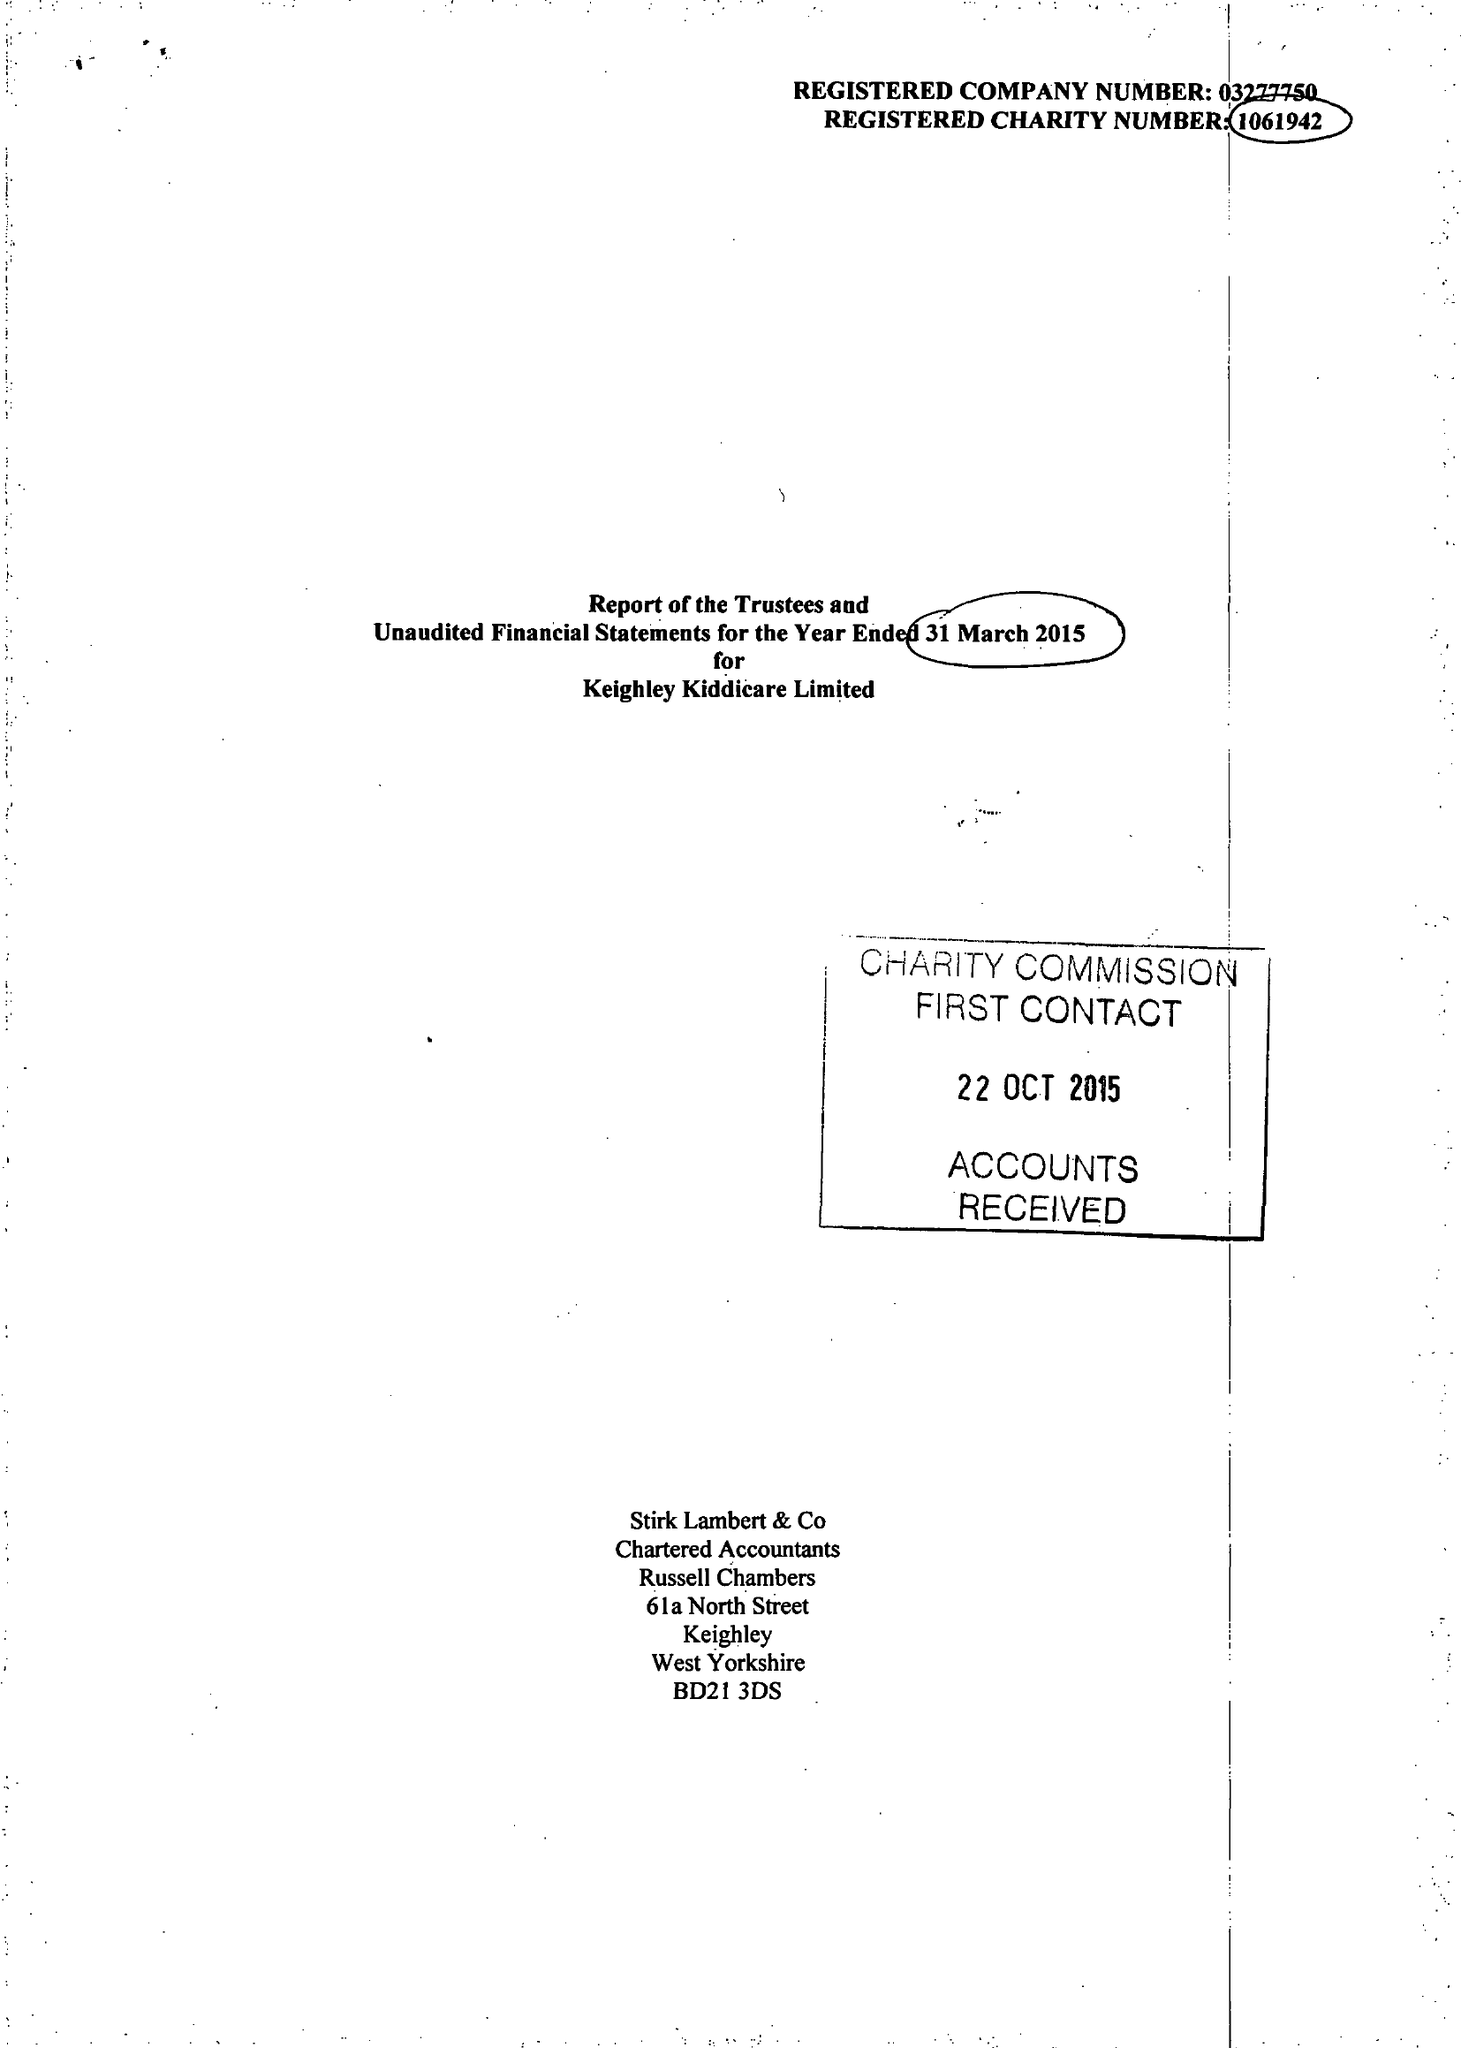What is the value for the income_annually_in_british_pounds?
Answer the question using a single word or phrase. 442759.00 